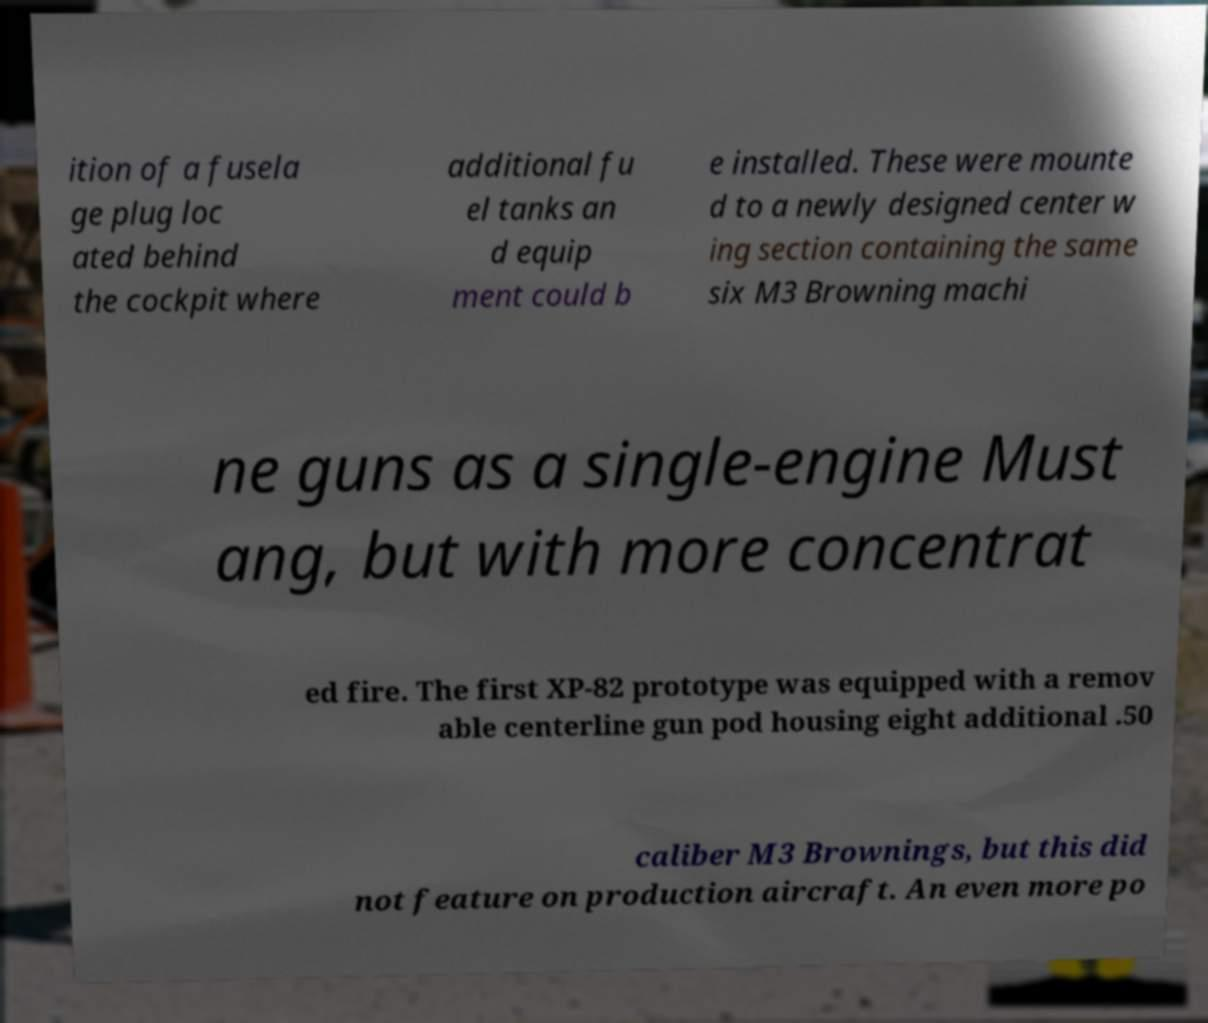Please read and relay the text visible in this image. What does it say? ition of a fusela ge plug loc ated behind the cockpit where additional fu el tanks an d equip ment could b e installed. These were mounte d to a newly designed center w ing section containing the same six M3 Browning machi ne guns as a single-engine Must ang, but with more concentrat ed fire. The first XP-82 prototype was equipped with a remov able centerline gun pod housing eight additional .50 caliber M3 Brownings, but this did not feature on production aircraft. An even more po 